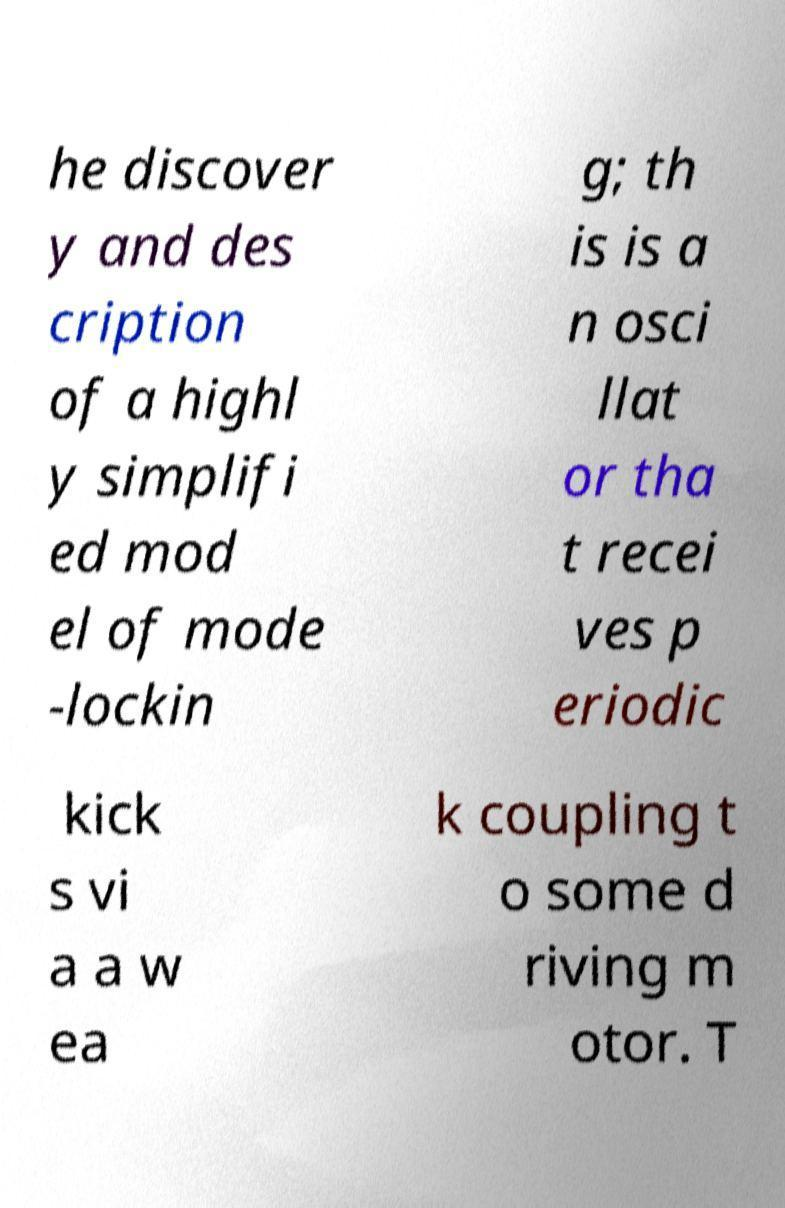There's text embedded in this image that I need extracted. Can you transcribe it verbatim? he discover y and des cription of a highl y simplifi ed mod el of mode -lockin g; th is is a n osci llat or tha t recei ves p eriodic kick s vi a a w ea k coupling t o some d riving m otor. T 